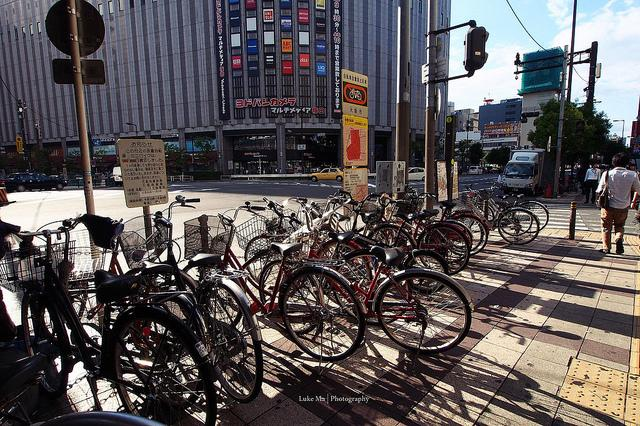Where are the owners of these bikes while this photo was taken?

Choices:
A) at work
B) overseas
C) skydiving
D) home at work 